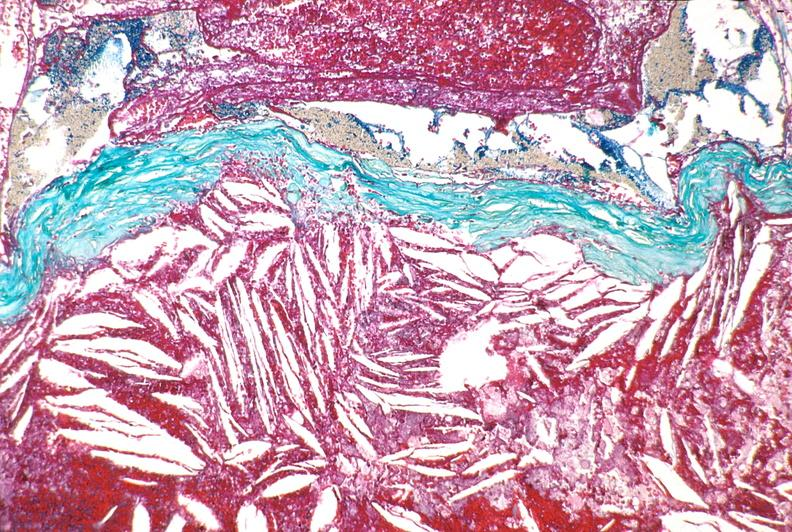s cardiovascular present?
Answer the question using a single word or phrase. Yes 